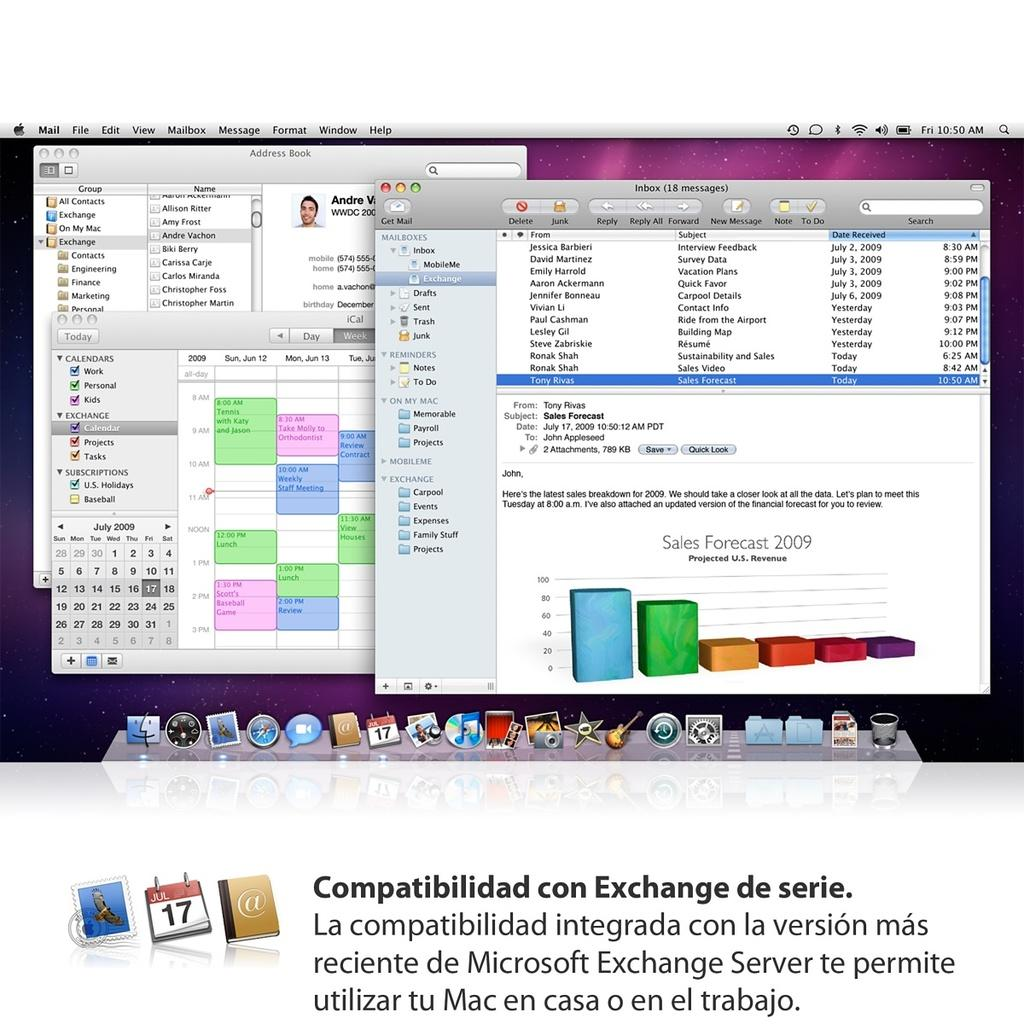<image>
Provide a brief description of the given image. A computer screen is shown with mail, file, edit and view shown at the top left. 